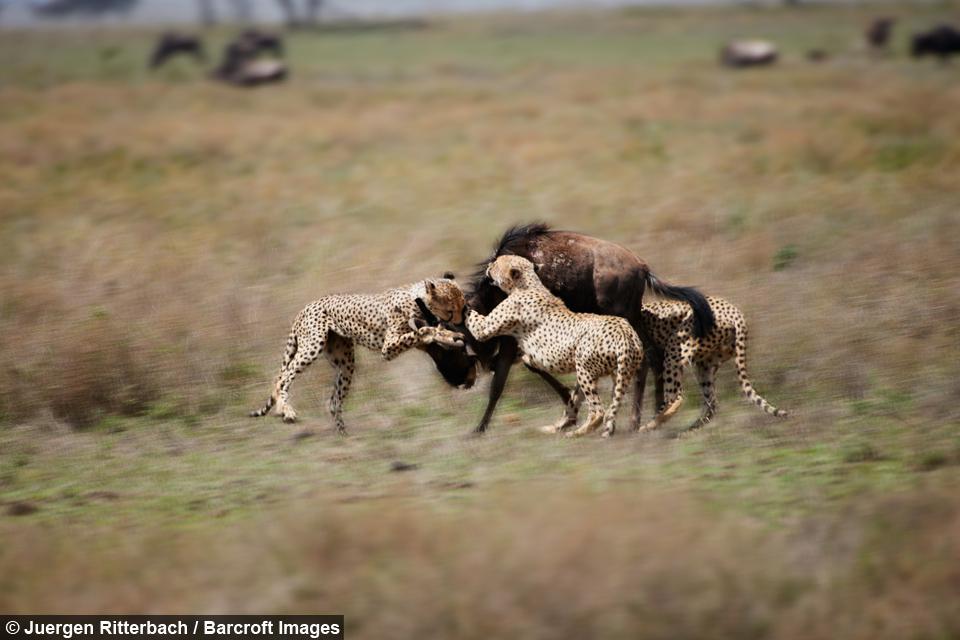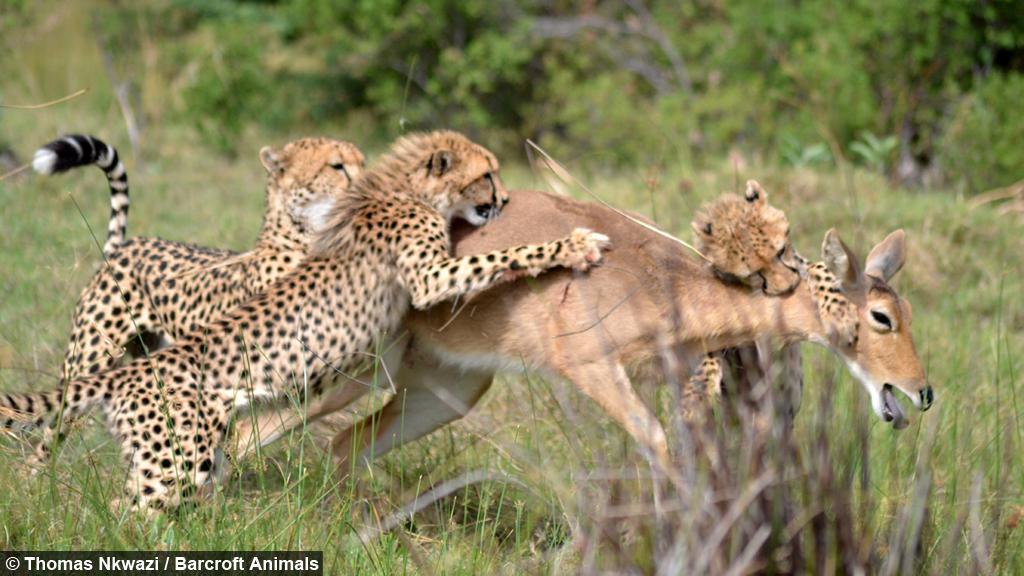The first image is the image on the left, the second image is the image on the right. Evaluate the accuracy of this statement regarding the images: "There are no more than four cheetahs.". Is it true? Answer yes or no. No. The first image is the image on the left, the second image is the image on the right. For the images displayed, is the sentence "Left image shows spotted wild cats attacking an upright hooved animal." factually correct? Answer yes or no. Yes. 